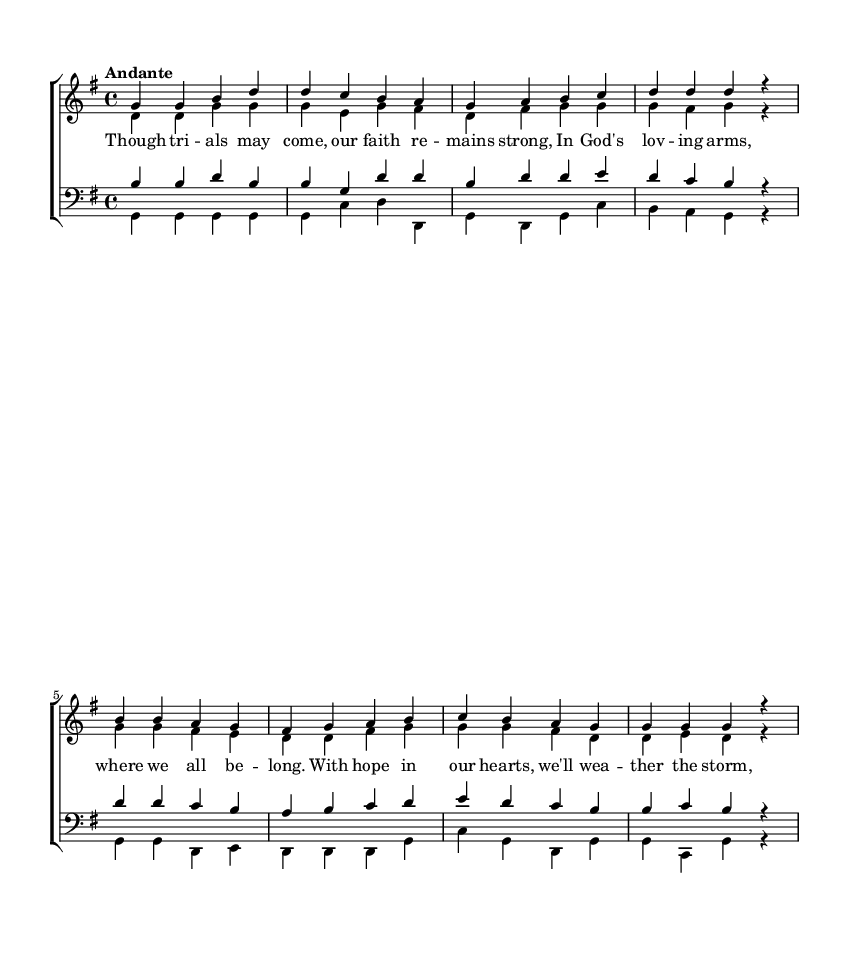What is the key signature of this music? The key signature is G major, which has one sharp (F#). You can identify the key signature by observing the sharp signs on the staff, which indicate the key of G major.
Answer: G major What is the time signature of this music? The time signature is 4/4, commonly known as "common time." This is indicated by the two numbers at the beginning of the score, where the top number shows there are four beats in a measure, and the bottom number indicates that a quarter note receives one beat.
Answer: 4/4 What tempo marking is given in the score? The tempo marking is Andante, which indicates a moderate pace. You can find this information in the markings above the staff, which provide guidance on how fast or slow the music should be played.
Answer: Andante How many voices are there in this choir arrangement? There are four voices in this choir arrangement: soprano, alto, tenor, and bass. This is determined by looking at the different staves for each voice part indicated at the beginning of the score.
Answer: Four What is the theme expressed in the lyrics of the music? The theme expressed in the lyrics is about faith and perseverance. By reading the words beneath the notes, one can see how they convey trust in God's love and strength in facing trials.
Answer: Faith and perseverance Which voice part has the highest range in this arrangement? The soprano voice part has the highest range. This can be concluded by comparing the written notes in each voice part; soprano music consistently uses higher pitches than the other parts.
Answer: Soprano What is the purpose of the fermata symbols in this music? The purpose of the fermata symbols is to indicate that the note should be held longer than its normal duration, which adds expressive emphasis. To find these symbols, look for dots placed above or below the notes in the score, indicating where to pause longer.
Answer: To sustain notes 